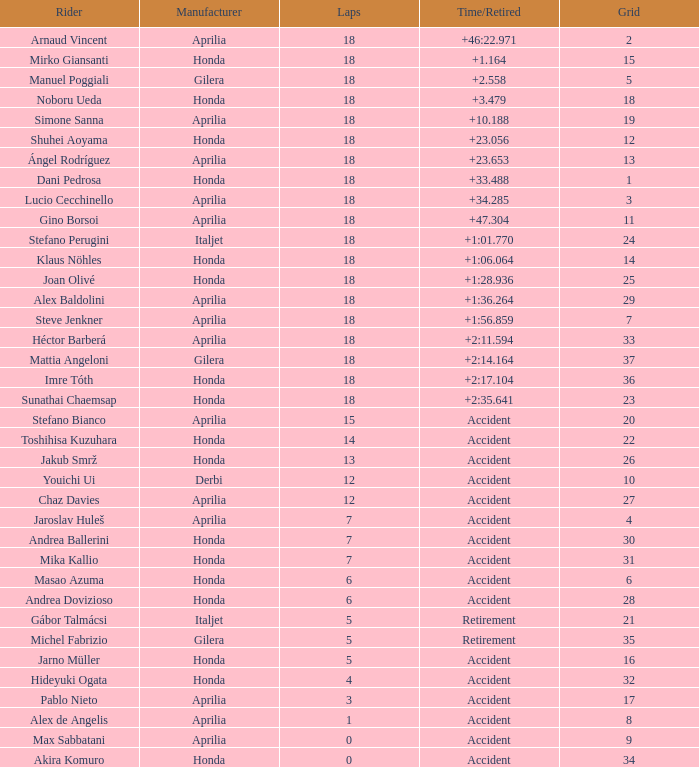Which rider has completed fewer than 15 laps, participated in over 32 grids, and experienced an accident or retirement? Akira Komuro. 